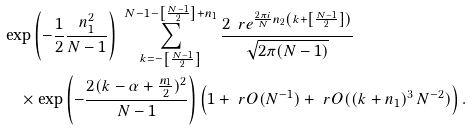Convert formula to latex. <formula><loc_0><loc_0><loc_500><loc_500>& \exp { \left ( - \frac { 1 } { 2 } \frac { n _ { 1 } ^ { 2 } } { N - 1 } \right ) } \ \sum _ { k = - \left [ \frac { N - 1 } { 2 } \right ] } ^ { N - 1 - \left [ \frac { N - 1 } { 2 } \right ] + n _ { 1 } } \frac { 2 \, \ r e ^ { \frac { 2 \pi i } { N } n _ { 2 } \left ( k + \left [ \frac { N - 1 } { 2 } \right ] \right ) } } { \sqrt { 2 \pi ( N - 1 ) } } \\ & \quad \times \exp { \left ( - \frac { 2 ( k - \alpha + \frac { n _ { 1 } } { 2 } ) ^ { 2 } } { N - 1 } \right ) } \left ( 1 + \ r O ( N ^ { - 1 } ) + \ r O ( ( k + n _ { 1 } ) ^ { 3 } \, N ^ { - 2 } ) \right ) .</formula> 